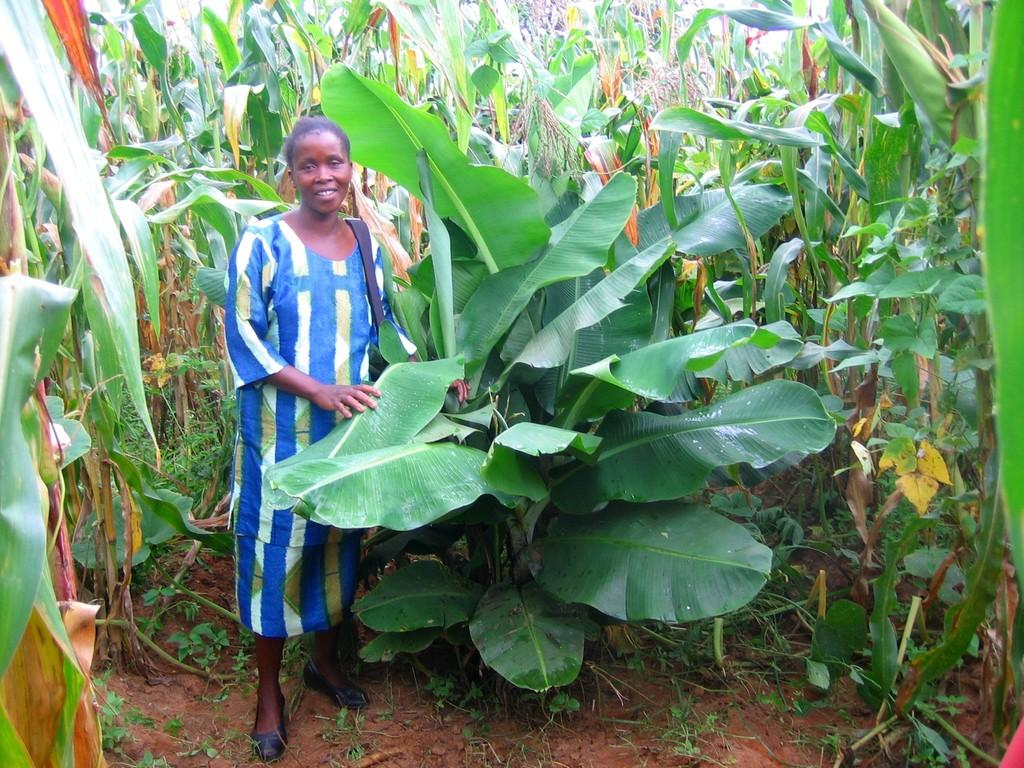Who is present in the image? There is a woman in the image. What is the woman wearing? The woman is wearing a bag. Where is the woman standing? The woman is standing on land. What is the woman holding in the image? The woman is holding leaves. What type of vegetation can be seen in the image? There are plants visible in the image. Can you see a harbor in the image? There is no harbor present in the image. --- Facts: 1. There is a car in the image. 2. The car is red. 3. The car has four wheels. 4. The car is parked on the street. 5. There are people walking on the sidewalk. Absurd Topics: elephant, piano Conversation: What is the main subject in the image? There is a car in the image. What color is the car? The car is red. How many wheels does the car have? The car has four wheels. Where is the car located in the image? The car is parked on the street. What else can be seen in the image? There are people walking on the sidewalk. Reasoning: Let's think step by step in order to produce the conversation. We start by identifying the main subject of the image, which is the car. Next, we describe specific features of the car, such as its color and the number of wheels it has. Then, we observe the location of the car, which is parked on the street. Finally, we mention other elements present in the image, such as the people walking on the sidewalk. Absurd Question/Answer: Can you hear the elephant playing the piano in the image? There is no elephant or piano present in the image. --- Facts: 1. There is a group of people in the image. 2. The people are wearing hats. 3. The people are holding hands. 4. The people are standing in front of a building. 5. The building has a large clock on its facade. Absurd Topics: ice cream, parrot, trampoline Conversation: How many people are in the image? There is a group of people in the image. What are the people wearing on their heads? The people are wearing hats. What are the people doing in the image? The people are holding hands. Where are the people standing in the image? The people are standing in front of a building. What feature of the building can be seen in the image? The building has a large clock on its facade. Reasoning: Let's think step by step in order to produce the conversation. We start by identifying the main subject of the image, which is the group of people. Next, we describe specific features of the people, such as their clothing and the 